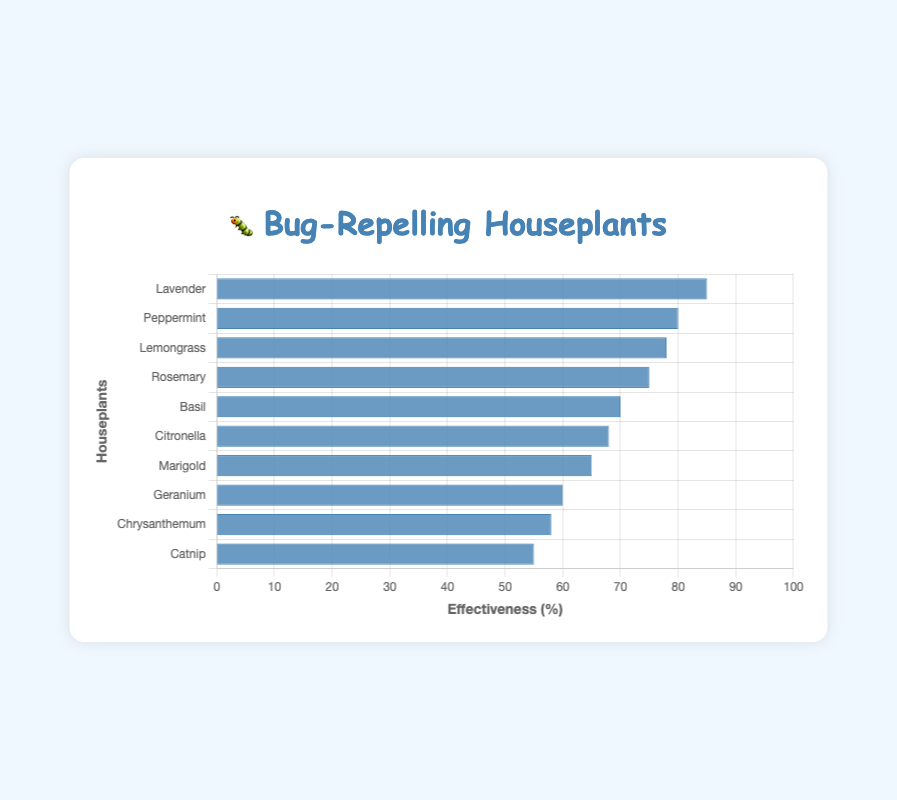What is the most effective houseplant for repelling bugs? The bar chart shows the effectiveness of each houseplant against bugs, arranged from highest to lowest effectiveness. By looking at the top of the chart, the most effective houseplant is identified.
Answer: Lavender How much more effective is Lavender compared to Catnip in repelling bugs? To find the difference in effectiveness, subtract the effectiveness value of Catnip (55) from that of Lavender (85). 85 - 55 gives the difference.
Answer: 30 Which houseplant has an effectiveness closest to 70%? The bar closest to 70% effectiveness in the bar chart represents the houseplant we're looking for. By inspecting the chart, Basil is identified.
Answer: Basil What is the total effectiveness score if we combine Peppermint and Citronella? To find the total, add the effectiveness percentages of Peppermint (80) and Citronella (68). 80 + 68 gives the combined total.
Answer: 148 List the houseplants with an effectiveness of more than 75% against bugs. By highlighting bars with an effectiveness higher than 75%, we identify Lavender (85), Peppermint (80), and Lemongrass (78). They all have effectiveness greater than 75%.
Answer: Lavender, Peppermint, Lemongrass How many houseplants have an effectiveness against bugs of 60% or higher? Count the number of bars that have values 60% or higher in effectiveness. Lavender, Peppermint, Lemongrass, Rosemary, Basil, Citronella, Marigold, and Geranium give us a total of 8 houseplants.
Answer: 8 Which houseplant is less effective against bugs: Chrysanthemum or Marigold? Compare the effectiveness percentages of Chrysanthemum (58) and Marigold (65). By visual inspection, Chrysanthemum is found to be less effective.
Answer: Chrysanthemum What is the average effectiveness of the top five houseplants? Identify the effectiveness values for the top five houseplants (Lavender, Peppermint, Lemongrass, Rosemary, and Basil) and calculate the average. (85 + 80 + 78 + 75 + 70) / 5 gives the average.
Answer: 77.6 Arrange the houseplants in ascending order of their effectiveness against bugs. Reorder the houseplants based on the bar heights from shortest to tallest: Catnip, Chrysanthemum, Geranium, Marigold, Citronella, Basil, Rosemary, Lemongrass, Peppermint, Lavender.
Answer: Catnip, Chrysanthemum, Geranium, Marigold, Citronella, Basil, Rosemary, Lemongrass, Peppermint, Lavender Which houseplant has the middle effectiveness value when all are sorted in descending order? First, sort the effectiveness values in descending order and find the middle value. By counting, we see that the 5th value in a list of 10 is Basil with 70% effectiveness.
Answer: Basil 